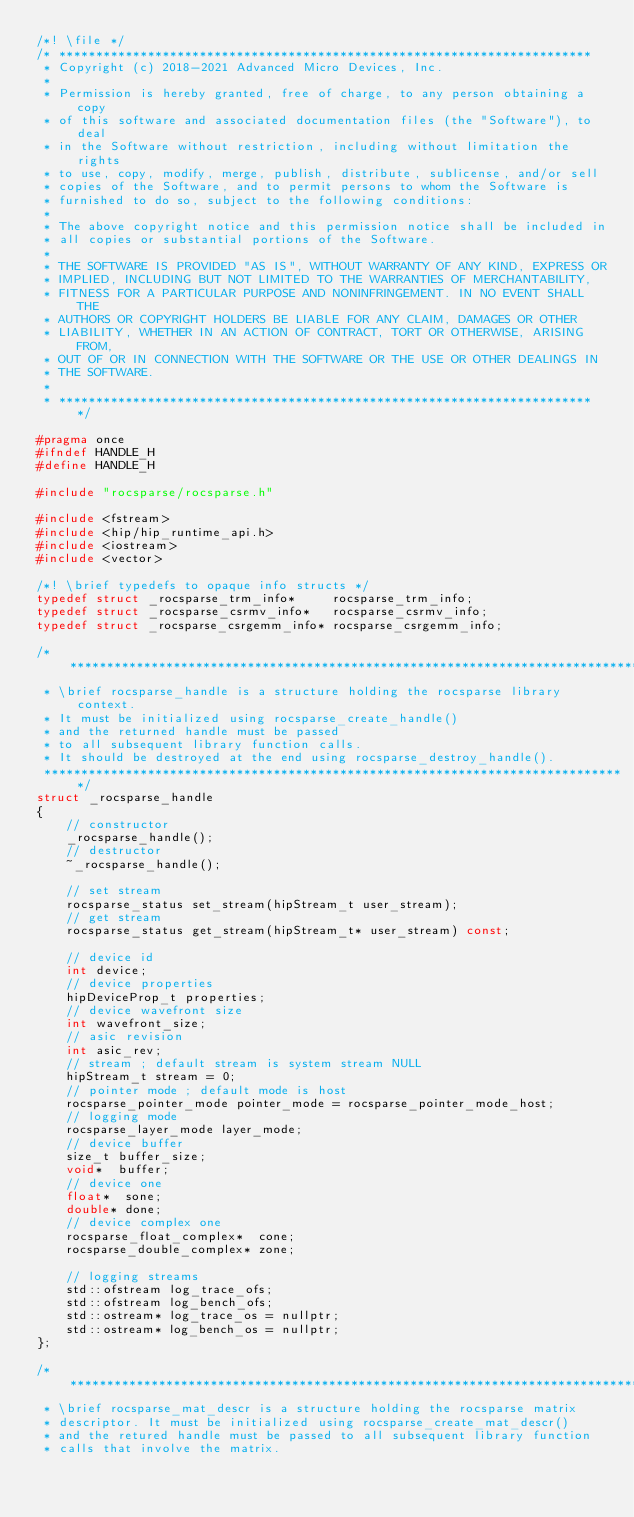Convert code to text. <code><loc_0><loc_0><loc_500><loc_500><_C_>/*! \file */
/* ************************************************************************
 * Copyright (c) 2018-2021 Advanced Micro Devices, Inc.
 *
 * Permission is hereby granted, free of charge, to any person obtaining a copy
 * of this software and associated documentation files (the "Software"), to deal
 * in the Software without restriction, including without limitation the rights
 * to use, copy, modify, merge, publish, distribute, sublicense, and/or sell
 * copies of the Software, and to permit persons to whom the Software is
 * furnished to do so, subject to the following conditions:
 *
 * The above copyright notice and this permission notice shall be included in
 * all copies or substantial portions of the Software.
 *
 * THE SOFTWARE IS PROVIDED "AS IS", WITHOUT WARRANTY OF ANY KIND, EXPRESS OR
 * IMPLIED, INCLUDING BUT NOT LIMITED TO THE WARRANTIES OF MERCHANTABILITY,
 * FITNESS FOR A PARTICULAR PURPOSE AND NONINFRINGEMENT. IN NO EVENT SHALL THE
 * AUTHORS OR COPYRIGHT HOLDERS BE LIABLE FOR ANY CLAIM, DAMAGES OR OTHER
 * LIABILITY, WHETHER IN AN ACTION OF CONTRACT, TORT OR OTHERWISE, ARISING FROM,
 * OUT OF OR IN CONNECTION WITH THE SOFTWARE OR THE USE OR OTHER DEALINGS IN
 * THE SOFTWARE.
 *
 * ************************************************************************ */

#pragma once
#ifndef HANDLE_H
#define HANDLE_H

#include "rocsparse/rocsparse.h"

#include <fstream>
#include <hip/hip_runtime_api.h>
#include <iostream>
#include <vector>

/*! \brief typedefs to opaque info structs */
typedef struct _rocsparse_trm_info*     rocsparse_trm_info;
typedef struct _rocsparse_csrmv_info*   rocsparse_csrmv_info;
typedef struct _rocsparse_csrgemm_info* rocsparse_csrgemm_info;

/********************************************************************************
 * \brief rocsparse_handle is a structure holding the rocsparse library context.
 * It must be initialized using rocsparse_create_handle()
 * and the returned handle must be passed
 * to all subsequent library function calls.
 * It should be destroyed at the end using rocsparse_destroy_handle().
 *******************************************************************************/
struct _rocsparse_handle
{
    // constructor
    _rocsparse_handle();
    // destructor
    ~_rocsparse_handle();

    // set stream
    rocsparse_status set_stream(hipStream_t user_stream);
    // get stream
    rocsparse_status get_stream(hipStream_t* user_stream) const;

    // device id
    int device;
    // device properties
    hipDeviceProp_t properties;
    // device wavefront size
    int wavefront_size;
    // asic revision
    int asic_rev;
    // stream ; default stream is system stream NULL
    hipStream_t stream = 0;
    // pointer mode ; default mode is host
    rocsparse_pointer_mode pointer_mode = rocsparse_pointer_mode_host;
    // logging mode
    rocsparse_layer_mode layer_mode;
    // device buffer
    size_t buffer_size;
    void*  buffer;
    // device one
    float*  sone;
    double* done;
    // device complex one
    rocsparse_float_complex*  cone;
    rocsparse_double_complex* zone;

    // logging streams
    std::ofstream log_trace_ofs;
    std::ofstream log_bench_ofs;
    std::ostream* log_trace_os = nullptr;
    std::ostream* log_bench_os = nullptr;
};

/********************************************************************************
 * \brief rocsparse_mat_descr is a structure holding the rocsparse matrix
 * descriptor. It must be initialized using rocsparse_create_mat_descr()
 * and the retured handle must be passed to all subsequent library function
 * calls that involve the matrix.</code> 